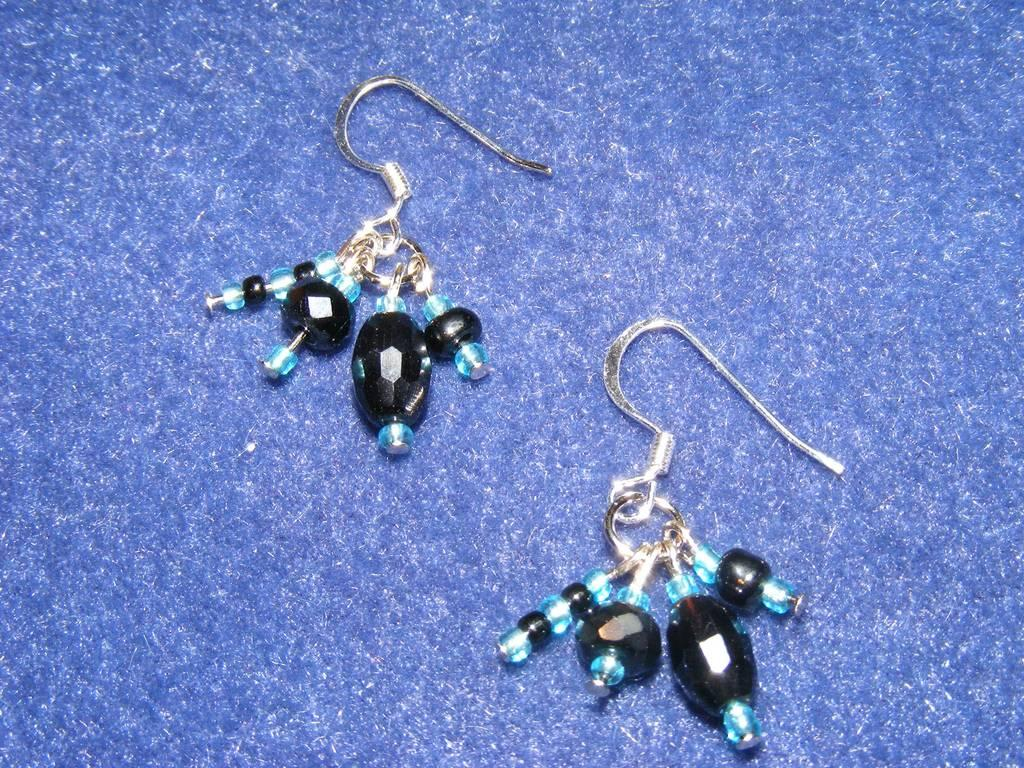What type of jewelry can be seen in the image? There are earrings in the image. Where are the earrings located in the image? The earrings are placed on the surface of the floor. What type of cake is being prepared in the image? There is no cake present in the image; it only features earrings placed on the floor. 